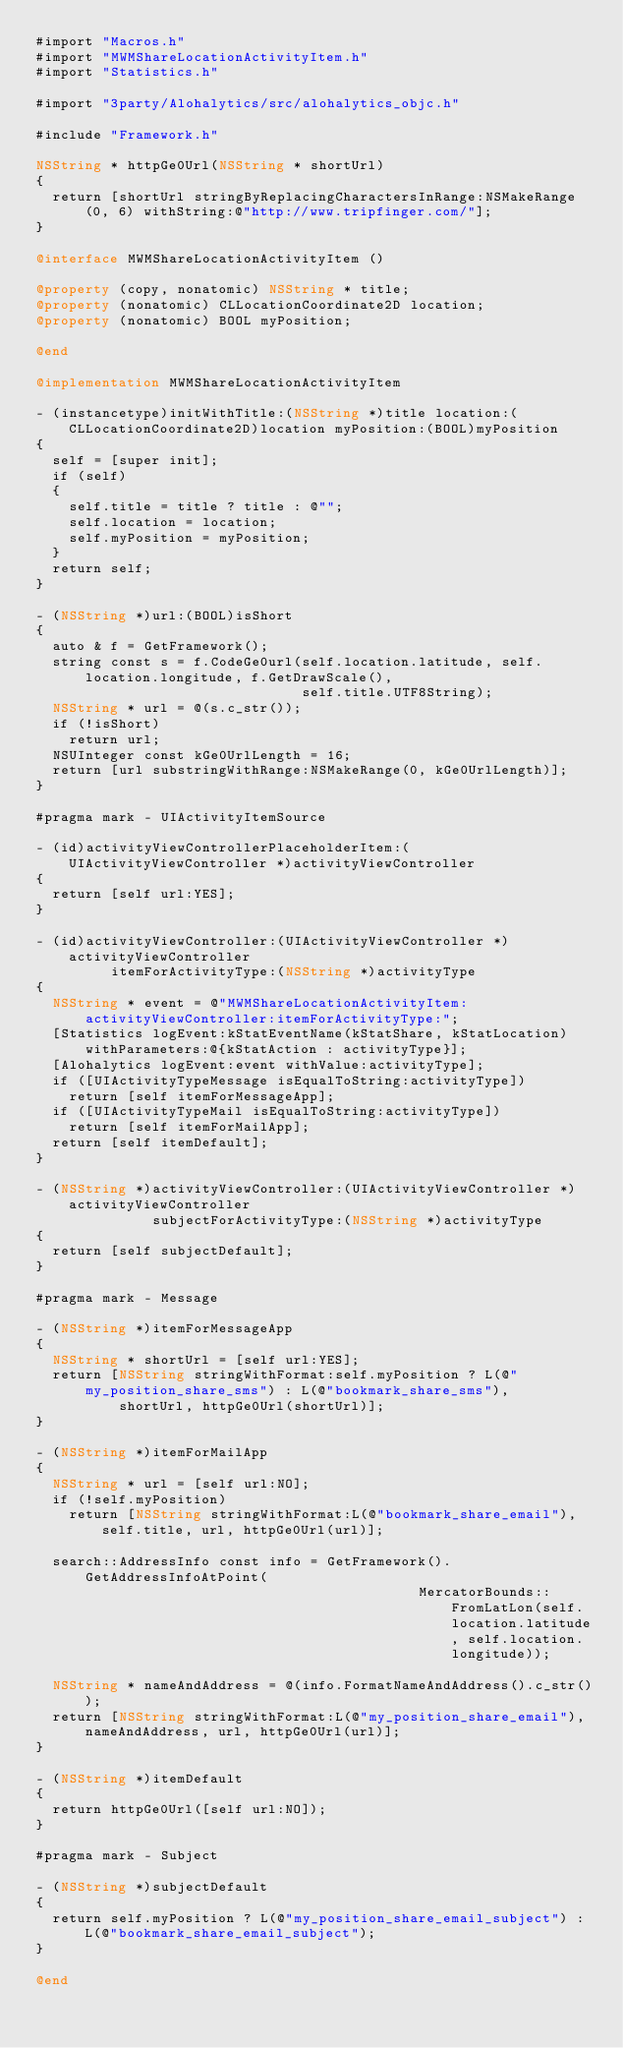<code> <loc_0><loc_0><loc_500><loc_500><_ObjectiveC_>#import "Macros.h"
#import "MWMShareLocationActivityItem.h"
#import "Statistics.h"

#import "3party/Alohalytics/src/alohalytics_objc.h"

#include "Framework.h"

NSString * httpGe0Url(NSString * shortUrl)
{
  return [shortUrl stringByReplacingCharactersInRange:NSMakeRange(0, 6) withString:@"http://www.tripfinger.com/"];
}

@interface MWMShareLocationActivityItem ()

@property (copy, nonatomic) NSString * title;
@property (nonatomic) CLLocationCoordinate2D location;
@property (nonatomic) BOOL myPosition;

@end

@implementation MWMShareLocationActivityItem

- (instancetype)initWithTitle:(NSString *)title location:(CLLocationCoordinate2D)location myPosition:(BOOL)myPosition
{
  self = [super init];
  if (self)
  {
    self.title = title ? title : @"";
    self.location = location;
    self.myPosition = myPosition;
  }
  return self;
}

- (NSString *)url:(BOOL)isShort
{
  auto & f = GetFramework();
  string const s = f.CodeGe0url(self.location.latitude, self.location.longitude, f.GetDrawScale(),
                                self.title.UTF8String);
  NSString * url = @(s.c_str());
  if (!isShort)
    return url;
  NSUInteger const kGe0UrlLength = 16;
  return [url substringWithRange:NSMakeRange(0, kGe0UrlLength)];
}

#pragma mark - UIActivityItemSource

- (id)activityViewControllerPlaceholderItem:(UIActivityViewController *)activityViewController
{
  return [self url:YES];
}

- (id)activityViewController:(UIActivityViewController *)activityViewController
         itemForActivityType:(NSString *)activityType
{
  NSString * event = @"MWMShareLocationActivityItem:activityViewController:itemForActivityType:";
  [Statistics logEvent:kStatEventName(kStatShare, kStatLocation) withParameters:@{kStatAction : activityType}];
  [Alohalytics logEvent:event withValue:activityType];
  if ([UIActivityTypeMessage isEqualToString:activityType])
    return [self itemForMessageApp];
  if ([UIActivityTypeMail isEqualToString:activityType])
    return [self itemForMailApp];
  return [self itemDefault];
}

- (NSString *)activityViewController:(UIActivityViewController *)activityViewController
              subjectForActivityType:(NSString *)activityType
{
  return [self subjectDefault];
}

#pragma mark - Message

- (NSString *)itemForMessageApp
{
  NSString * shortUrl = [self url:YES];
  return [NSString stringWithFormat:self.myPosition ? L(@"my_position_share_sms") : L(@"bookmark_share_sms"),
          shortUrl, httpGe0Url(shortUrl)];
}

- (NSString *)itemForMailApp
{
  NSString * url = [self url:NO];
  if (!self.myPosition)
    return [NSString stringWithFormat:L(@"bookmark_share_email"), self.title, url, httpGe0Url(url)];

  search::AddressInfo const info = GetFramework().GetAddressInfoAtPoint(
                                              MercatorBounds::FromLatLon(self.location.latitude, self.location.longitude));

  NSString * nameAndAddress = @(info.FormatNameAndAddress().c_str());
  return [NSString stringWithFormat:L(@"my_position_share_email"), nameAndAddress, url, httpGe0Url(url)];
}

- (NSString *)itemDefault
{
  return httpGe0Url([self url:NO]);
}

#pragma mark - Subject

- (NSString *)subjectDefault
{
  return self.myPosition ? L(@"my_position_share_email_subject") : L(@"bookmark_share_email_subject");
}

@end</code> 